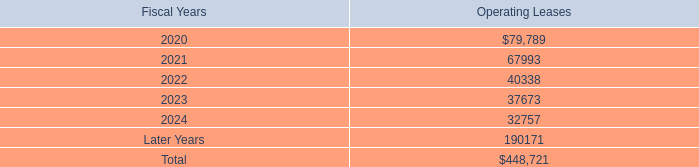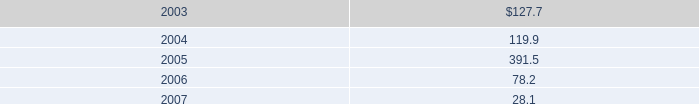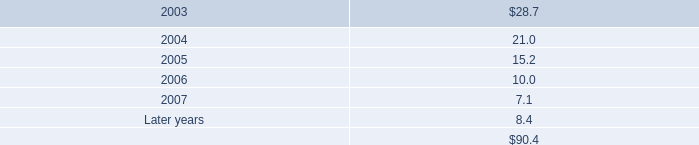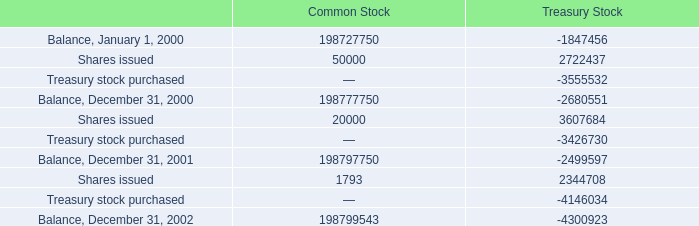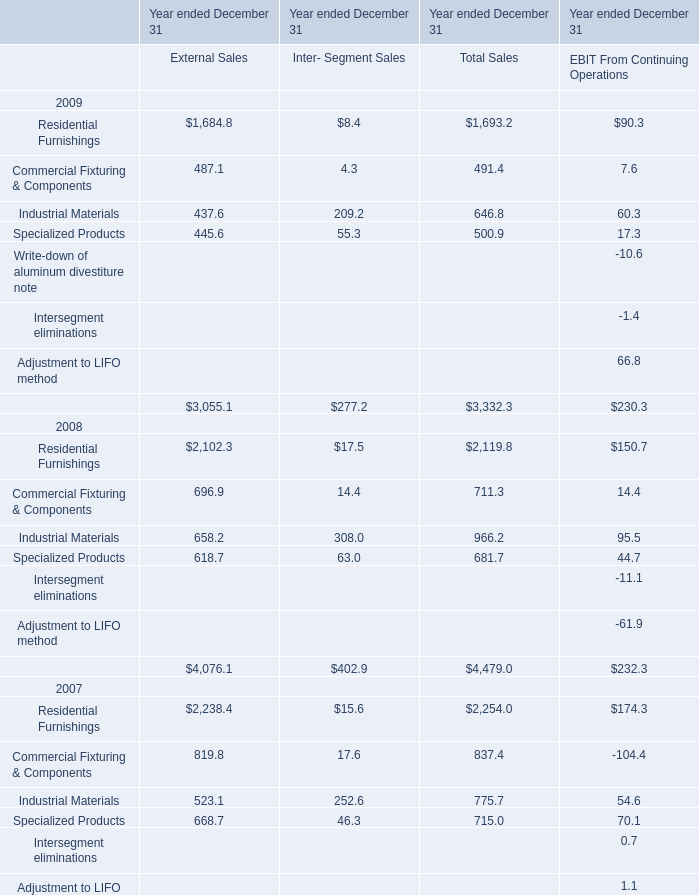What is the total amount of Balance, December 31, 2002 of Common Stock, and Residential Furnishings of Year ended December 31 External Sales ? 
Computations: (198799543.0 + 1684.8)
Answer: 198801227.8. 